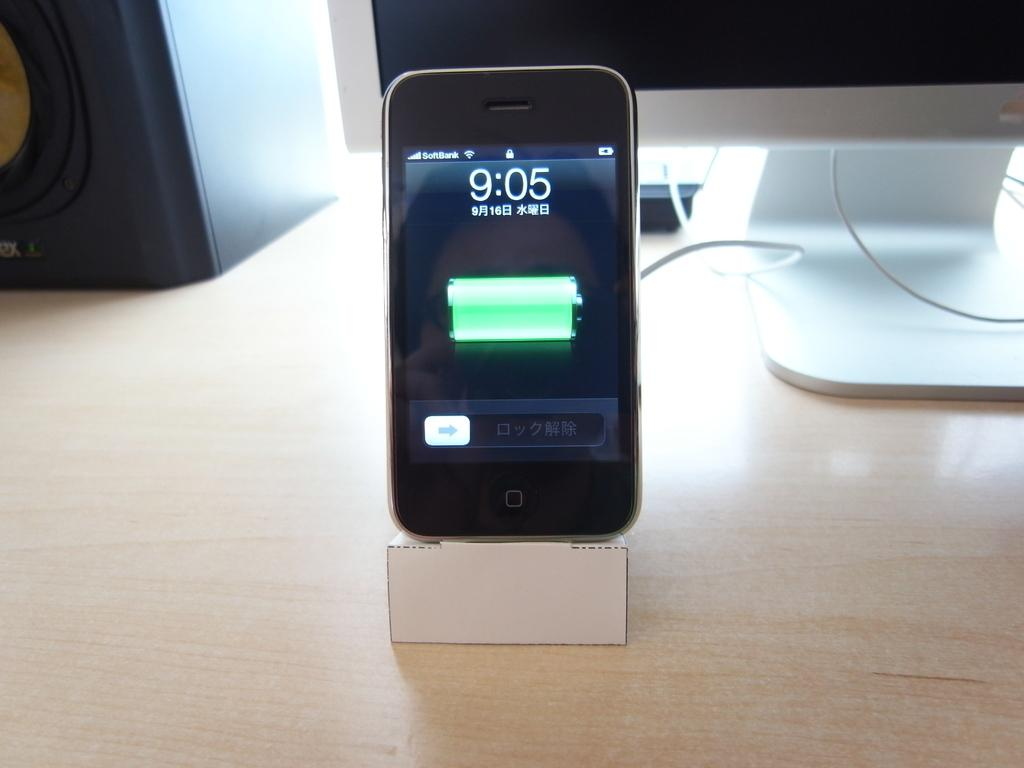<image>
Present a compact description of the photo's key features. An iPhone on a charging dock says that it is 9:05 right now. 